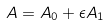Convert formula to latex. <formula><loc_0><loc_0><loc_500><loc_500>A = A _ { 0 } + \epsilon A _ { 1 }</formula> 